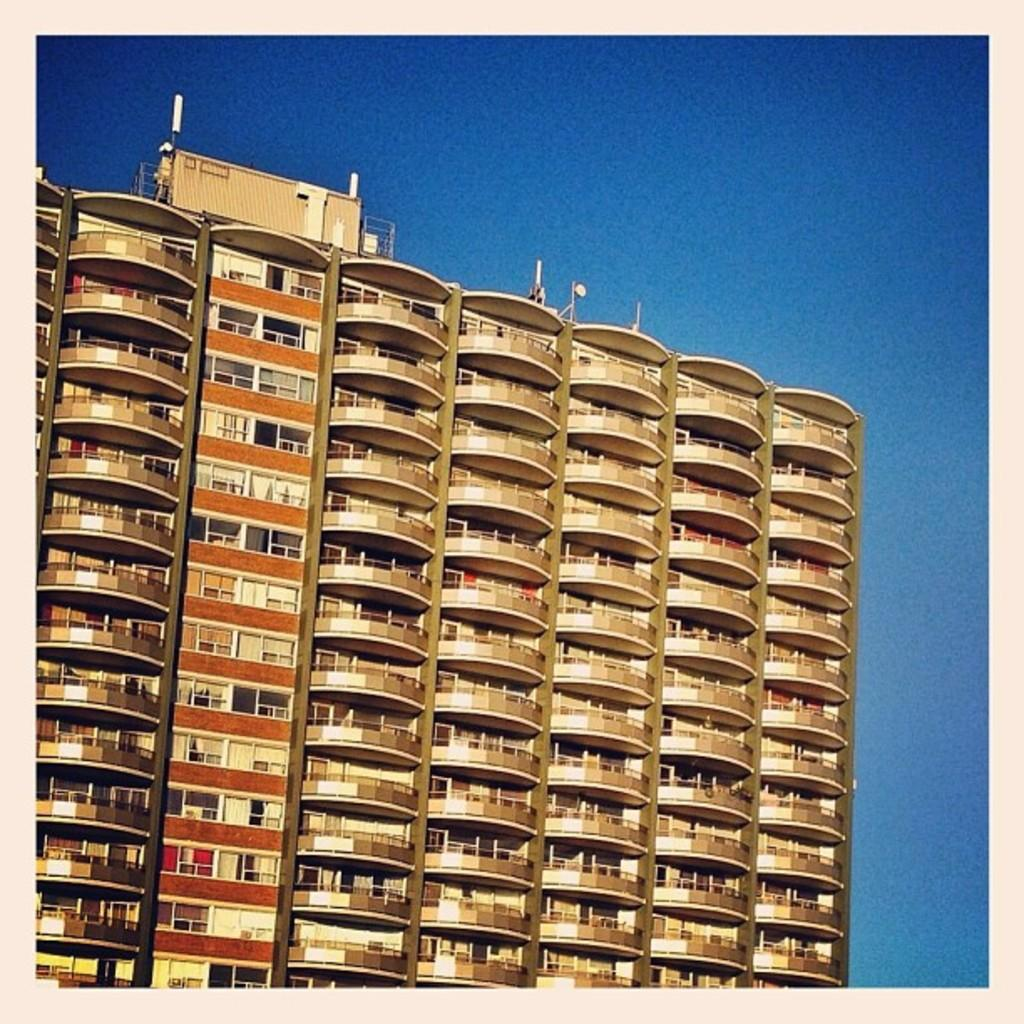What type of structure is present in the image? There is a building in the image. Can you describe the color of the building? The building is cream-colored. What can be seen in the background of the image? The sky is visible in the background of the image. How many trucks are parked in front of the building in the image? There are no trucks visible in the image; it only features a building and the sky in the background. 